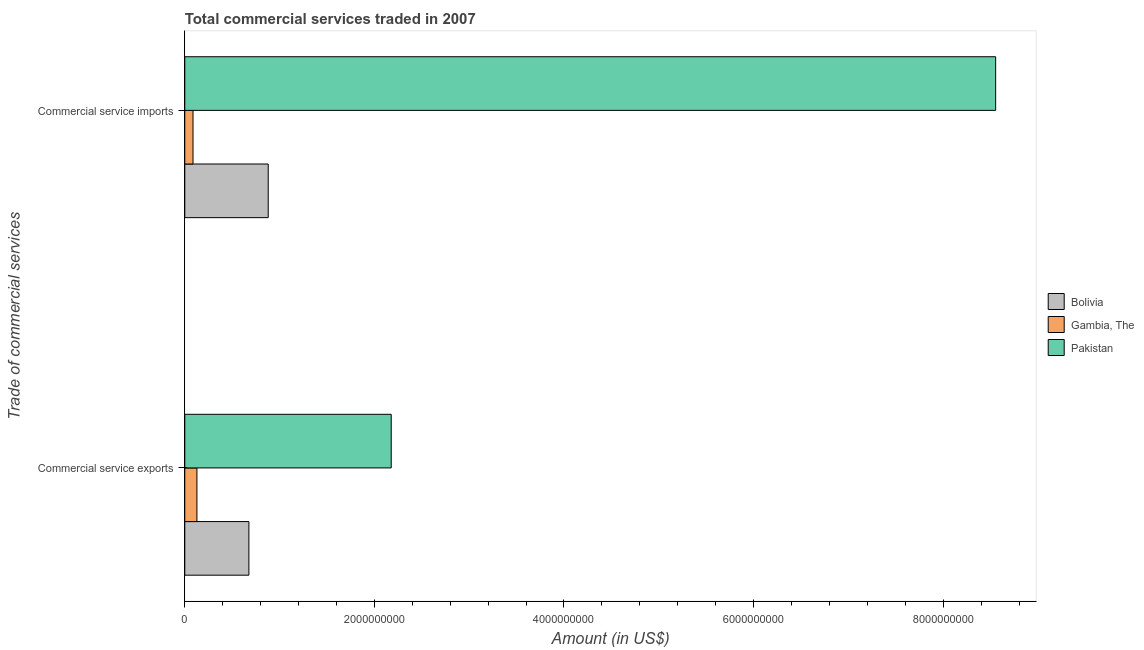Are the number of bars per tick equal to the number of legend labels?
Provide a short and direct response. Yes. Are the number of bars on each tick of the Y-axis equal?
Provide a succinct answer. Yes. How many bars are there on the 1st tick from the top?
Your answer should be very brief. 3. How many bars are there on the 1st tick from the bottom?
Provide a succinct answer. 3. What is the label of the 1st group of bars from the top?
Your answer should be compact. Commercial service imports. What is the amount of commercial service imports in Bolivia?
Provide a succinct answer. 8.80e+08. Across all countries, what is the maximum amount of commercial service exports?
Ensure brevity in your answer.  2.18e+09. Across all countries, what is the minimum amount of commercial service imports?
Provide a succinct answer. 8.68e+07. In which country was the amount of commercial service imports minimum?
Offer a very short reply. Gambia, The. What is the total amount of commercial service exports in the graph?
Offer a terse response. 2.98e+09. What is the difference between the amount of commercial service exports in Pakistan and that in Gambia, The?
Your answer should be very brief. 2.05e+09. What is the difference between the amount of commercial service imports in Gambia, The and the amount of commercial service exports in Pakistan?
Your answer should be compact. -2.09e+09. What is the average amount of commercial service exports per country?
Offer a terse response. 9.94e+08. What is the difference between the amount of commercial service imports and amount of commercial service exports in Bolivia?
Provide a succinct answer. 2.04e+08. In how many countries, is the amount of commercial service imports greater than 3600000000 US$?
Your answer should be very brief. 1. What is the ratio of the amount of commercial service exports in Pakistan to that in Gambia, The?
Give a very brief answer. 17.02. What does the 1st bar from the top in Commercial service imports represents?
Offer a very short reply. Pakistan. What does the 1st bar from the bottom in Commercial service imports represents?
Keep it short and to the point. Bolivia. How many bars are there?
Provide a succinct answer. 6. Are all the bars in the graph horizontal?
Offer a very short reply. Yes. How many countries are there in the graph?
Make the answer very short. 3. Are the values on the major ticks of X-axis written in scientific E-notation?
Offer a very short reply. No. Does the graph contain any zero values?
Offer a terse response. No. Where does the legend appear in the graph?
Provide a succinct answer. Center right. How many legend labels are there?
Make the answer very short. 3. What is the title of the graph?
Keep it short and to the point. Total commercial services traded in 2007. What is the label or title of the X-axis?
Your answer should be very brief. Amount (in US$). What is the label or title of the Y-axis?
Offer a very short reply. Trade of commercial services. What is the Amount (in US$) of Bolivia in Commercial service exports?
Give a very brief answer. 6.76e+08. What is the Amount (in US$) in Gambia, The in Commercial service exports?
Keep it short and to the point. 1.28e+08. What is the Amount (in US$) in Pakistan in Commercial service exports?
Offer a terse response. 2.18e+09. What is the Amount (in US$) in Bolivia in Commercial service imports?
Your answer should be very brief. 8.80e+08. What is the Amount (in US$) of Gambia, The in Commercial service imports?
Your answer should be very brief. 8.68e+07. What is the Amount (in US$) in Pakistan in Commercial service imports?
Offer a terse response. 8.55e+09. Across all Trade of commercial services, what is the maximum Amount (in US$) of Bolivia?
Ensure brevity in your answer.  8.80e+08. Across all Trade of commercial services, what is the maximum Amount (in US$) in Gambia, The?
Make the answer very short. 1.28e+08. Across all Trade of commercial services, what is the maximum Amount (in US$) in Pakistan?
Make the answer very short. 8.55e+09. Across all Trade of commercial services, what is the minimum Amount (in US$) in Bolivia?
Provide a succinct answer. 6.76e+08. Across all Trade of commercial services, what is the minimum Amount (in US$) of Gambia, The?
Your response must be concise. 8.68e+07. Across all Trade of commercial services, what is the minimum Amount (in US$) of Pakistan?
Keep it short and to the point. 2.18e+09. What is the total Amount (in US$) in Bolivia in the graph?
Your response must be concise. 1.56e+09. What is the total Amount (in US$) in Gambia, The in the graph?
Keep it short and to the point. 2.15e+08. What is the total Amount (in US$) of Pakistan in the graph?
Provide a short and direct response. 1.07e+1. What is the difference between the Amount (in US$) of Bolivia in Commercial service exports and that in Commercial service imports?
Your answer should be compact. -2.04e+08. What is the difference between the Amount (in US$) of Gambia, The in Commercial service exports and that in Commercial service imports?
Offer a very short reply. 4.12e+07. What is the difference between the Amount (in US$) in Pakistan in Commercial service exports and that in Commercial service imports?
Ensure brevity in your answer.  -6.38e+09. What is the difference between the Amount (in US$) in Bolivia in Commercial service exports and the Amount (in US$) in Gambia, The in Commercial service imports?
Offer a very short reply. 5.90e+08. What is the difference between the Amount (in US$) in Bolivia in Commercial service exports and the Amount (in US$) in Pakistan in Commercial service imports?
Your answer should be compact. -7.88e+09. What is the difference between the Amount (in US$) in Gambia, The in Commercial service exports and the Amount (in US$) in Pakistan in Commercial service imports?
Make the answer very short. -8.43e+09. What is the average Amount (in US$) in Bolivia per Trade of commercial services?
Provide a succinct answer. 7.78e+08. What is the average Amount (in US$) of Gambia, The per Trade of commercial services?
Provide a short and direct response. 1.07e+08. What is the average Amount (in US$) in Pakistan per Trade of commercial services?
Offer a very short reply. 5.37e+09. What is the difference between the Amount (in US$) in Bolivia and Amount (in US$) in Gambia, The in Commercial service exports?
Keep it short and to the point. 5.48e+08. What is the difference between the Amount (in US$) in Bolivia and Amount (in US$) in Pakistan in Commercial service exports?
Offer a very short reply. -1.50e+09. What is the difference between the Amount (in US$) in Gambia, The and Amount (in US$) in Pakistan in Commercial service exports?
Offer a very short reply. -2.05e+09. What is the difference between the Amount (in US$) in Bolivia and Amount (in US$) in Gambia, The in Commercial service imports?
Offer a terse response. 7.93e+08. What is the difference between the Amount (in US$) of Bolivia and Amount (in US$) of Pakistan in Commercial service imports?
Ensure brevity in your answer.  -7.67e+09. What is the difference between the Amount (in US$) in Gambia, The and Amount (in US$) in Pakistan in Commercial service imports?
Give a very brief answer. -8.47e+09. What is the ratio of the Amount (in US$) in Bolivia in Commercial service exports to that in Commercial service imports?
Offer a terse response. 0.77. What is the ratio of the Amount (in US$) of Gambia, The in Commercial service exports to that in Commercial service imports?
Provide a short and direct response. 1.47. What is the ratio of the Amount (in US$) in Pakistan in Commercial service exports to that in Commercial service imports?
Your response must be concise. 0.25. What is the difference between the highest and the second highest Amount (in US$) of Bolivia?
Ensure brevity in your answer.  2.04e+08. What is the difference between the highest and the second highest Amount (in US$) in Gambia, The?
Your answer should be compact. 4.12e+07. What is the difference between the highest and the second highest Amount (in US$) of Pakistan?
Your response must be concise. 6.38e+09. What is the difference between the highest and the lowest Amount (in US$) of Bolivia?
Give a very brief answer. 2.04e+08. What is the difference between the highest and the lowest Amount (in US$) in Gambia, The?
Give a very brief answer. 4.12e+07. What is the difference between the highest and the lowest Amount (in US$) of Pakistan?
Make the answer very short. 6.38e+09. 